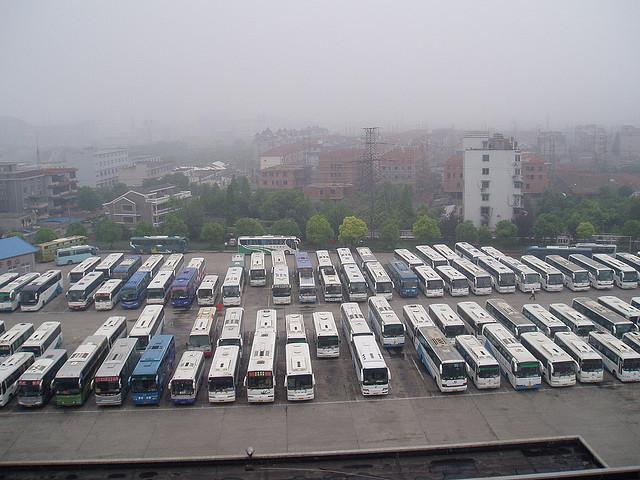What type of lot is this?
Select the correct answer and articulate reasoning with the following format: 'Answer: answer
Rationale: rationale.'
Options: Fairground, bus depot, used car, new car. Answer: bus depot.
Rationale: There are a lot of buses parked. 